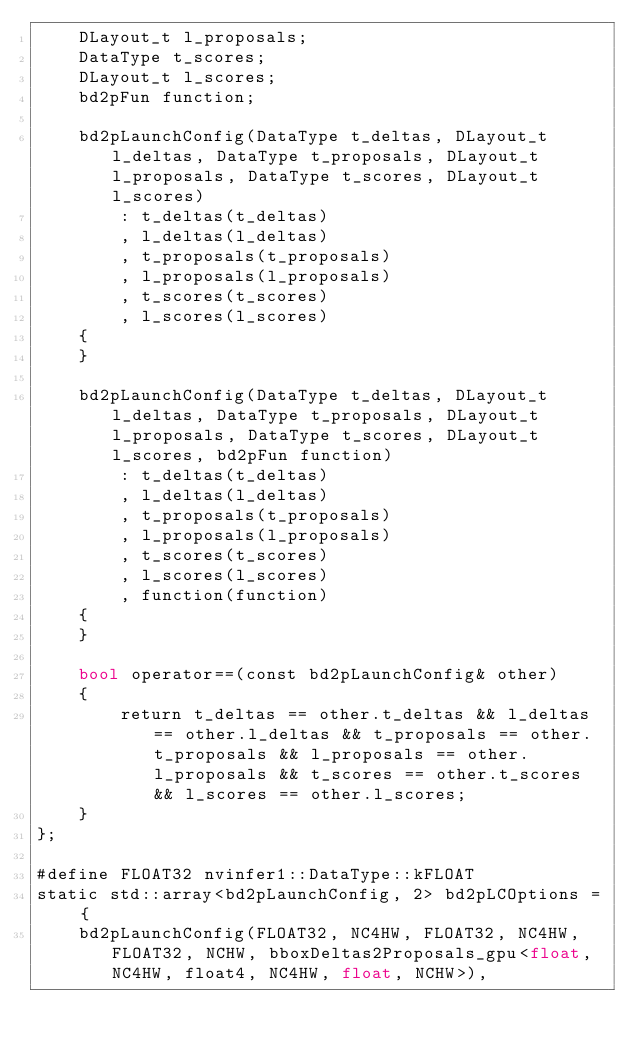<code> <loc_0><loc_0><loc_500><loc_500><_Cuda_>    DLayout_t l_proposals;
    DataType t_scores;
    DLayout_t l_scores;
    bd2pFun function;

    bd2pLaunchConfig(DataType t_deltas, DLayout_t l_deltas, DataType t_proposals, DLayout_t l_proposals, DataType t_scores, DLayout_t l_scores)
        : t_deltas(t_deltas)
        , l_deltas(l_deltas)
        , t_proposals(t_proposals)
        , l_proposals(l_proposals)
        , t_scores(t_scores)
        , l_scores(l_scores)
    {
    }

    bd2pLaunchConfig(DataType t_deltas, DLayout_t l_deltas, DataType t_proposals, DLayout_t l_proposals, DataType t_scores, DLayout_t l_scores, bd2pFun function)
        : t_deltas(t_deltas)
        , l_deltas(l_deltas)
        , t_proposals(t_proposals)
        , l_proposals(l_proposals)
        , t_scores(t_scores)
        , l_scores(l_scores)
        , function(function)
    {
    }

    bool operator==(const bd2pLaunchConfig& other)
    {
        return t_deltas == other.t_deltas && l_deltas == other.l_deltas && t_proposals == other.t_proposals && l_proposals == other.l_proposals && t_scores == other.t_scores && l_scores == other.l_scores;
    }
};

#define FLOAT32 nvinfer1::DataType::kFLOAT
static std::array<bd2pLaunchConfig, 2> bd2pLCOptions = {
    bd2pLaunchConfig(FLOAT32, NC4HW, FLOAT32, NC4HW, FLOAT32, NCHW, bboxDeltas2Proposals_gpu<float, NC4HW, float4, NC4HW, float, NCHW>),</code> 